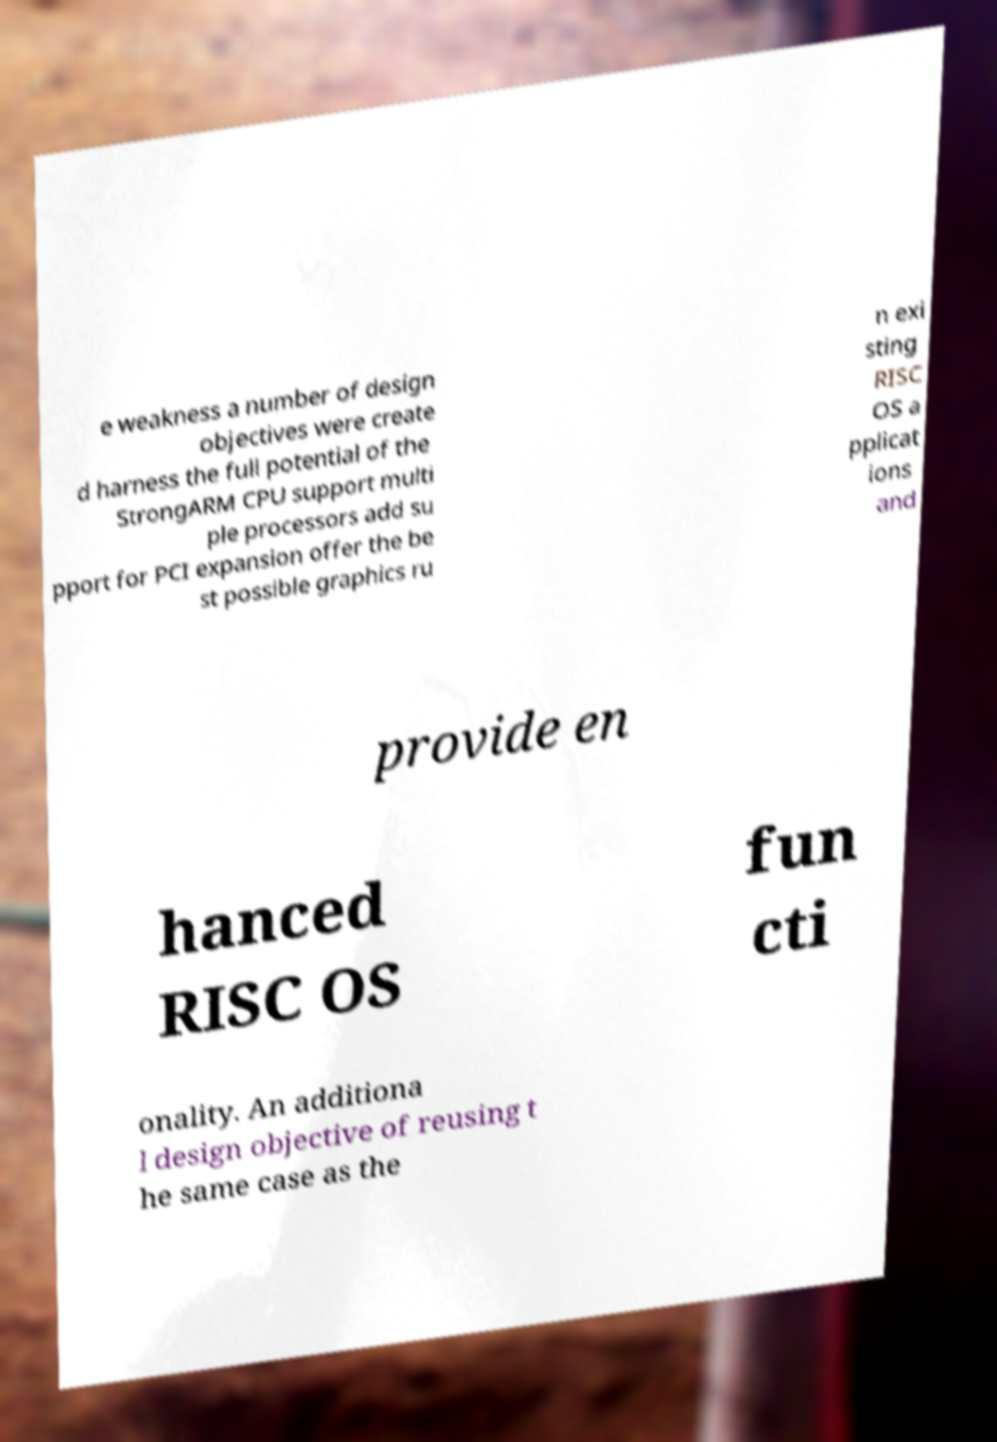Could you assist in decoding the text presented in this image and type it out clearly? e weakness a number of design objectives were create d harness the full potential of the StrongARM CPU support multi ple processors add su pport for PCI expansion offer the be st possible graphics ru n exi sting RISC OS a pplicat ions and provide en hanced RISC OS fun cti onality. An additiona l design objective of reusing t he same case as the 